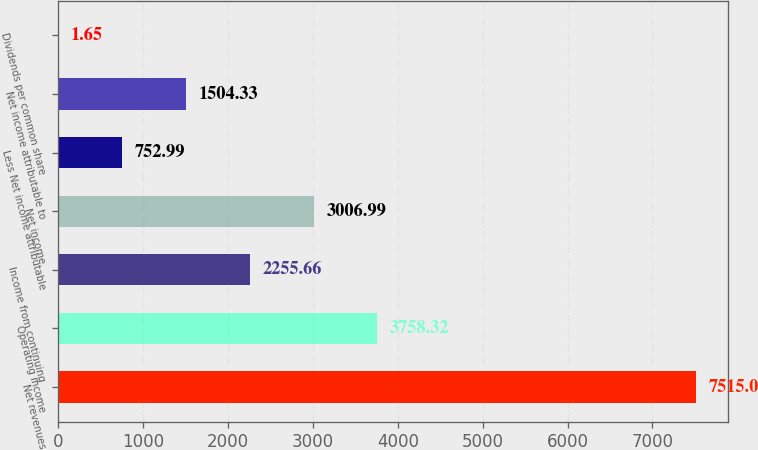<chart> <loc_0><loc_0><loc_500><loc_500><bar_chart><fcel>Net revenues<fcel>Operating income<fcel>Income from continuing<fcel>Net income<fcel>Less Net income attributable<fcel>Net income attributable to<fcel>Dividends per common share<nl><fcel>7515<fcel>3758.32<fcel>2255.66<fcel>3006.99<fcel>752.99<fcel>1504.33<fcel>1.65<nl></chart> 